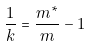Convert formula to latex. <formula><loc_0><loc_0><loc_500><loc_500>\frac { 1 } { k } = \frac { m ^ { * } } { m } - 1</formula> 